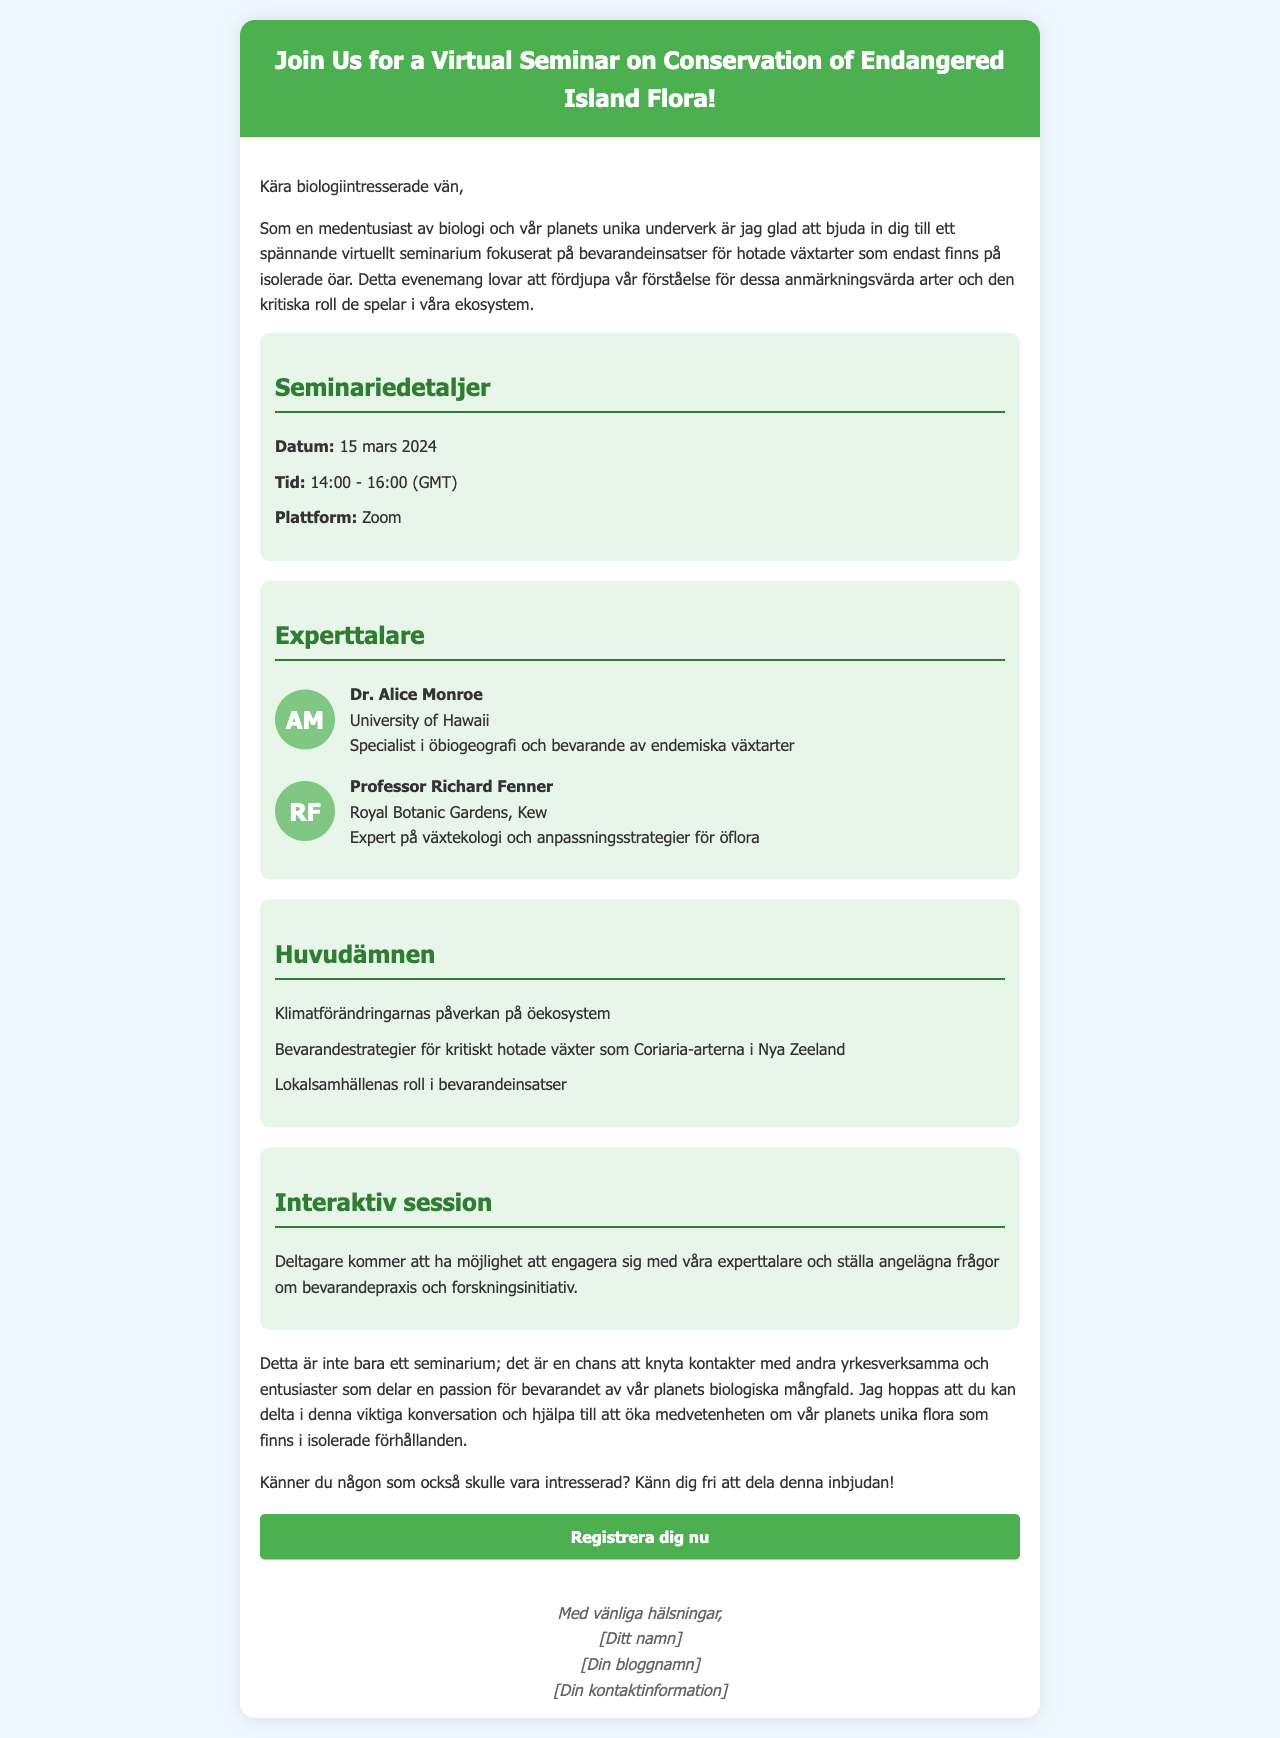Vad är datumet för seminariet? Datumet för seminariet framgår under seminariedetaljer och är den 15 mars 2024.
Answer: 15 mars 2024 Vilka två experttalare nämns i dokumentet? De experttalare som nämns är Dr. Alice Monroe och Professor Richard Fenner.
Answer: Dr. Alice Monroe, Professor Richard Fenner Vilken plattform används för seminariet? Plattformen för seminariet är nämnd under seminariedetaljer och är Zoom.
Answer: Zoom Vilket ämne handlar om klimatförändringarnas påverkan? Huvudämnet som handlar om klimatförändringar är "Klimatförändringarnas påverkan på öekosystem".
Answer: Klimatförändringarnas påverkan på öekosystem Vad är syftet med den interaktiva sessionen? Syftet med den interaktiva sessionen är att deltagare kan ställa frågor om bevarandepraxis och forskningsinitiativ.
Answer: Engagera med experttalare Vad kan deltagare vilken känsla att dela detta till exempel? Deltagare kan känna sig fria att dela inbjudan med andra som också kan vara intresserade.
Answer: Dela inbjudan Vilken typ av evenemang är detta? Evenemanget är ett virtuellt seminarium om bevarande av hotade öväxter.
Answer: Virtuellt seminarium 